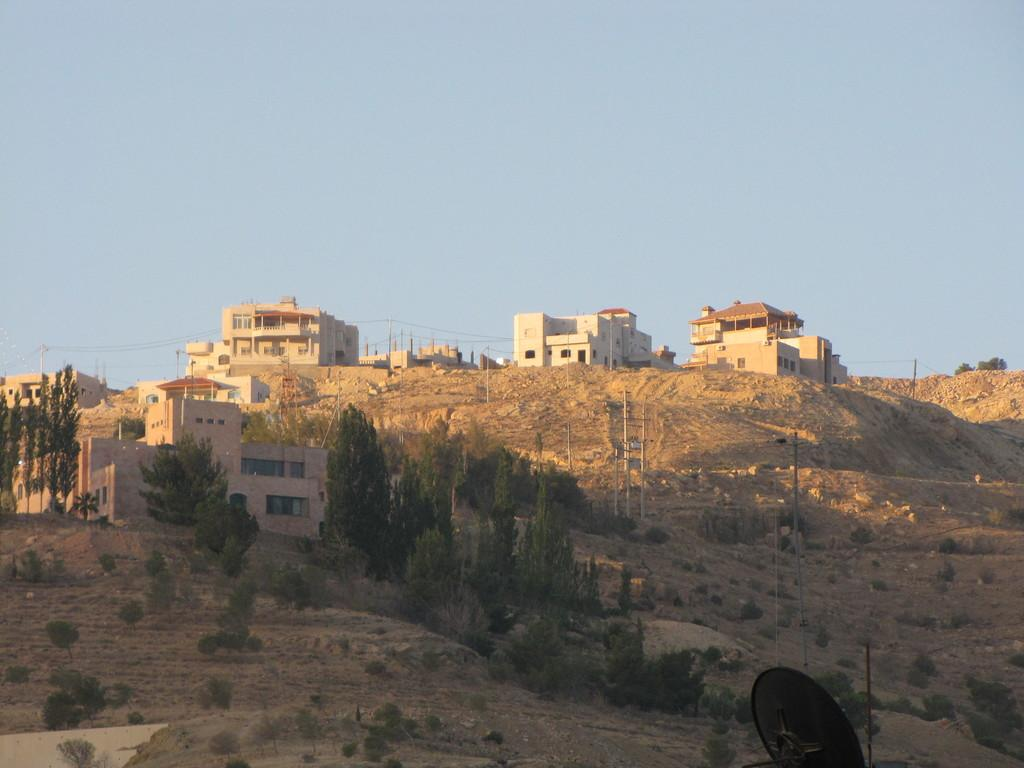What type of structures can be seen on the hills in the image? There are houses on the hills in the image. What utility infrastructure is present in the image? Current poles are present in the image. What type of vegetation is visible in the image? Trees are visible in the image. What else is present in the image besides the houses, current poles, and trees? Wires are present in the image. What can be seen in the background of the image? The sky is visible in the background of the image. How many sticks are leaning against the houses in the image? There are no sticks present in the image. 